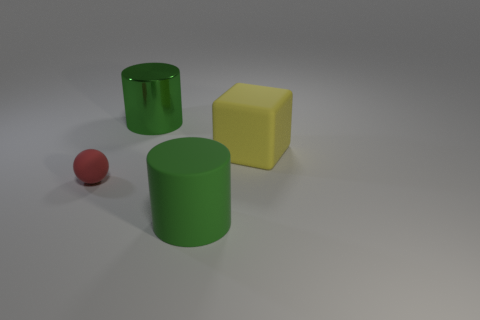There is a large thing that is the same color as the big metallic cylinder; what is it made of?
Offer a very short reply. Rubber. There is another big green thing that is the same shape as the large green metallic thing; what is its material?
Offer a very short reply. Rubber. There is a rubber thing that is in front of the red matte object; does it have the same size as the block?
Keep it short and to the point. Yes. What number of shiny things are either cylinders or blocks?
Your answer should be compact. 1. The large object that is behind the tiny rubber thing and on the left side of the yellow rubber thing is made of what material?
Your response must be concise. Metal. Is the red object made of the same material as the block?
Your answer should be compact. Yes. There is a object that is both in front of the yellow rubber object and to the right of the red rubber object; what is its size?
Provide a succinct answer. Large. The yellow thing has what shape?
Keep it short and to the point. Cube. How many things are either gray cylinders or big green things that are in front of the shiny cylinder?
Your answer should be very brief. 1. There is a cylinder that is on the right side of the large shiny cylinder; is it the same color as the large matte cube?
Offer a very short reply. No. 